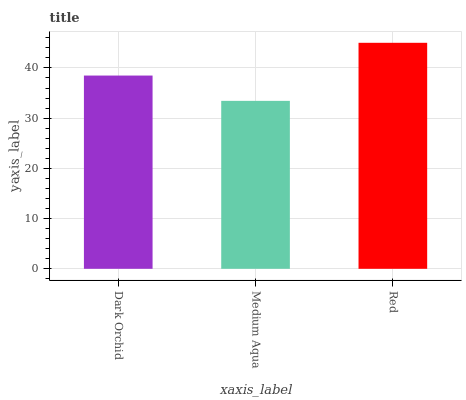Is Medium Aqua the minimum?
Answer yes or no. Yes. Is Red the maximum?
Answer yes or no. Yes. Is Red the minimum?
Answer yes or no. No. Is Medium Aqua the maximum?
Answer yes or no. No. Is Red greater than Medium Aqua?
Answer yes or no. Yes. Is Medium Aqua less than Red?
Answer yes or no. Yes. Is Medium Aqua greater than Red?
Answer yes or no. No. Is Red less than Medium Aqua?
Answer yes or no. No. Is Dark Orchid the high median?
Answer yes or no. Yes. Is Dark Orchid the low median?
Answer yes or no. Yes. Is Medium Aqua the high median?
Answer yes or no. No. Is Medium Aqua the low median?
Answer yes or no. No. 